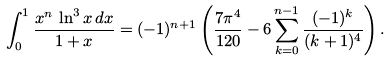<formula> <loc_0><loc_0><loc_500><loc_500>\int _ { 0 } ^ { 1 } \frac { x ^ { n } \, \ln ^ { 3 } x \, d x } { 1 + x } = ( - 1 ) ^ { n + 1 } \left ( \frac { 7 \pi ^ { 4 } } { 1 2 0 } - 6 \sum _ { k = 0 } ^ { n - 1 } \frac { ( - 1 ) ^ { k } } { ( k + 1 ) ^ { 4 } } \right ) .</formula> 